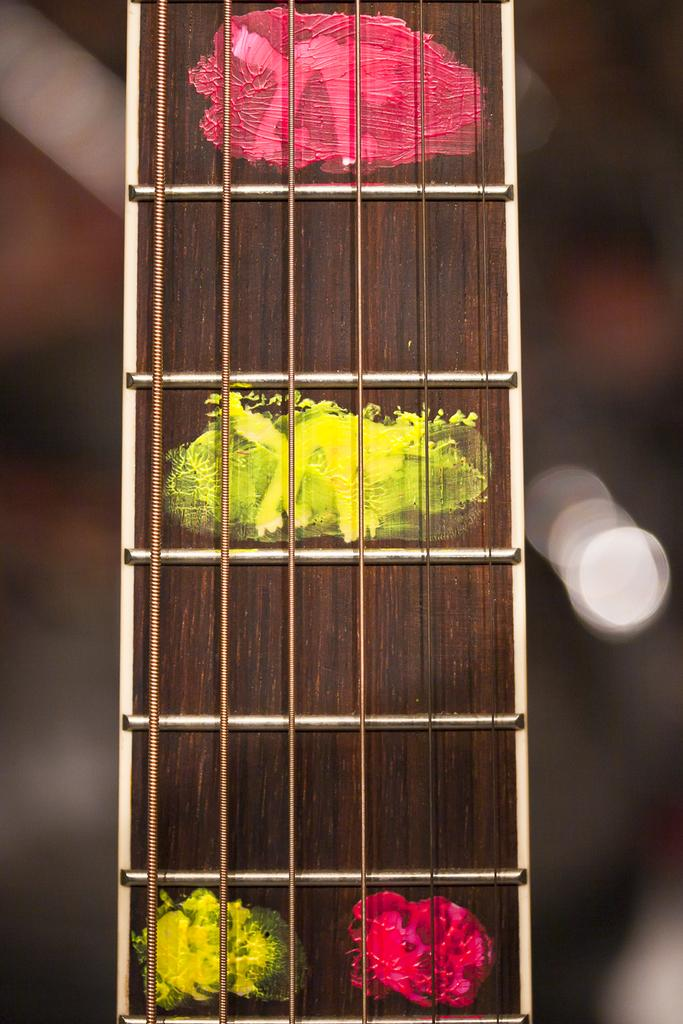What type of object can be seen in the image that is related to music? There are strings of a musical instrument in the image. Can you describe the background of the image? The background of the image is blurred. What religious symbol can be seen in the image? There is no religious symbol present in the image. Can you describe the person running in the image? There is no person running in the image; it only features strings of a musical instrument and a blurred background. 